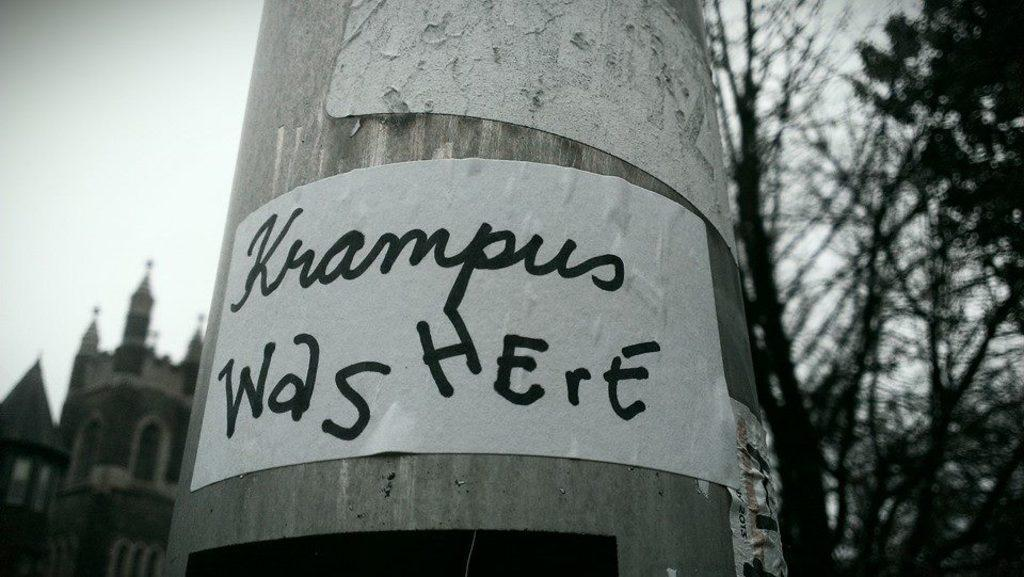What is the color scheme of the image? The image is black and white. What can be seen attached to a pole in the image? There are papers pasted on a pole in the image. What type of vegetation is visible in the image? There are branches of a tree visible in the image. What type of structure can be seen in the image? There is a building in the image. What is visible in the background of the image? The sky is visible in the image. How does the belief system of the tree branches affect the stream in the image? There is no belief system associated with the tree branches, and there is no stream present in the image. 